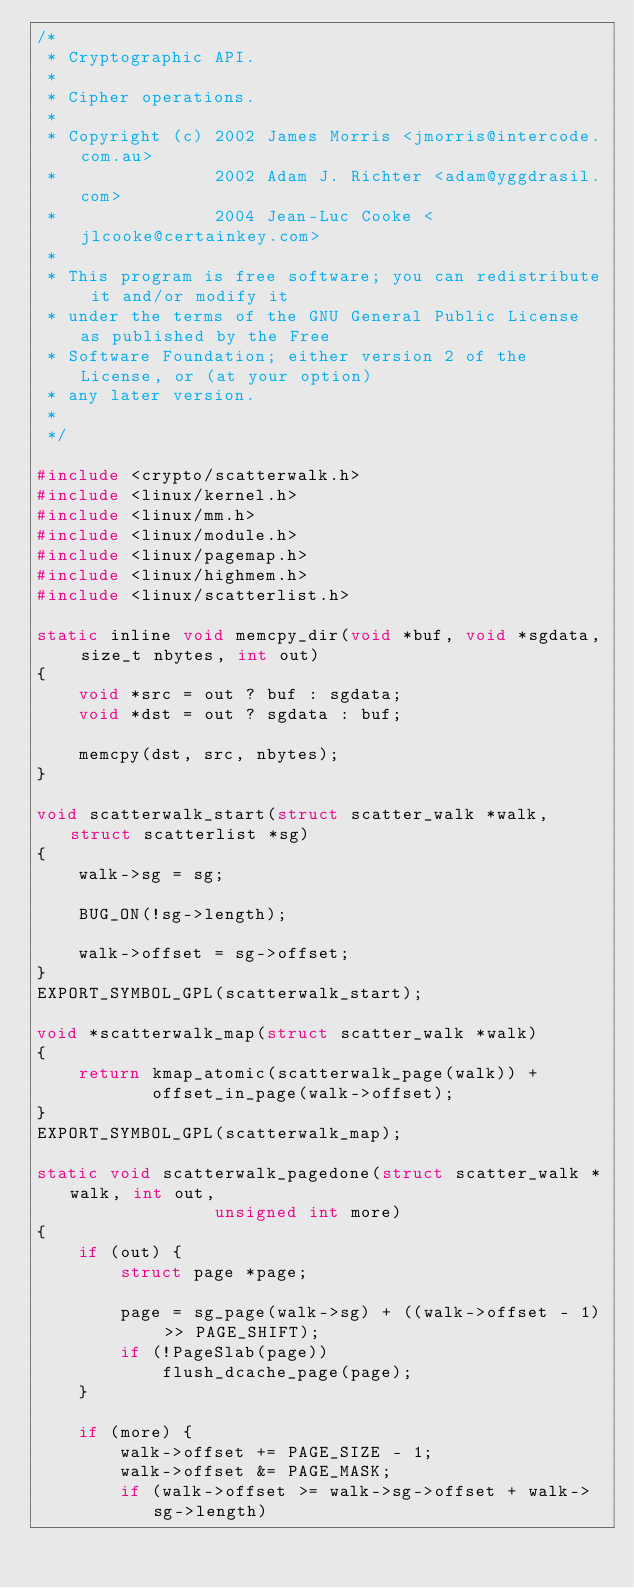<code> <loc_0><loc_0><loc_500><loc_500><_C_>/*
 * Cryptographic API.
 *
 * Cipher operations.
 *
 * Copyright (c) 2002 James Morris <jmorris@intercode.com.au>
 *               2002 Adam J. Richter <adam@yggdrasil.com>
 *               2004 Jean-Luc Cooke <jlcooke@certainkey.com>
 *
 * This program is free software; you can redistribute it and/or modify it
 * under the terms of the GNU General Public License as published by the Free
 * Software Foundation; either version 2 of the License, or (at your option)
 * any later version.
 *
 */

#include <crypto/scatterwalk.h>
#include <linux/kernel.h>
#include <linux/mm.h>
#include <linux/module.h>
#include <linux/pagemap.h>
#include <linux/highmem.h>
#include <linux/scatterlist.h>

static inline void memcpy_dir(void *buf, void *sgdata, size_t nbytes, int out)
{
	void *src = out ? buf : sgdata;
	void *dst = out ? sgdata : buf;

	memcpy(dst, src, nbytes);
}

void scatterwalk_start(struct scatter_walk *walk, struct scatterlist *sg)
{
	walk->sg = sg;

	BUG_ON(!sg->length);

	walk->offset = sg->offset;
}
EXPORT_SYMBOL_GPL(scatterwalk_start);

void *scatterwalk_map(struct scatter_walk *walk)
{
	return kmap_atomic(scatterwalk_page(walk)) +
	       offset_in_page(walk->offset);
}
EXPORT_SYMBOL_GPL(scatterwalk_map);

static void scatterwalk_pagedone(struct scatter_walk *walk, int out,
				 unsigned int more)
{
	if (out) {
		struct page *page;

		page = sg_page(walk->sg) + ((walk->offset - 1) >> PAGE_SHIFT);
		if (!PageSlab(page))
			flush_dcache_page(page);
	}

	if (more) {
		walk->offset += PAGE_SIZE - 1;
		walk->offset &= PAGE_MASK;
		if (walk->offset >= walk->sg->offset + walk->sg->length)</code> 